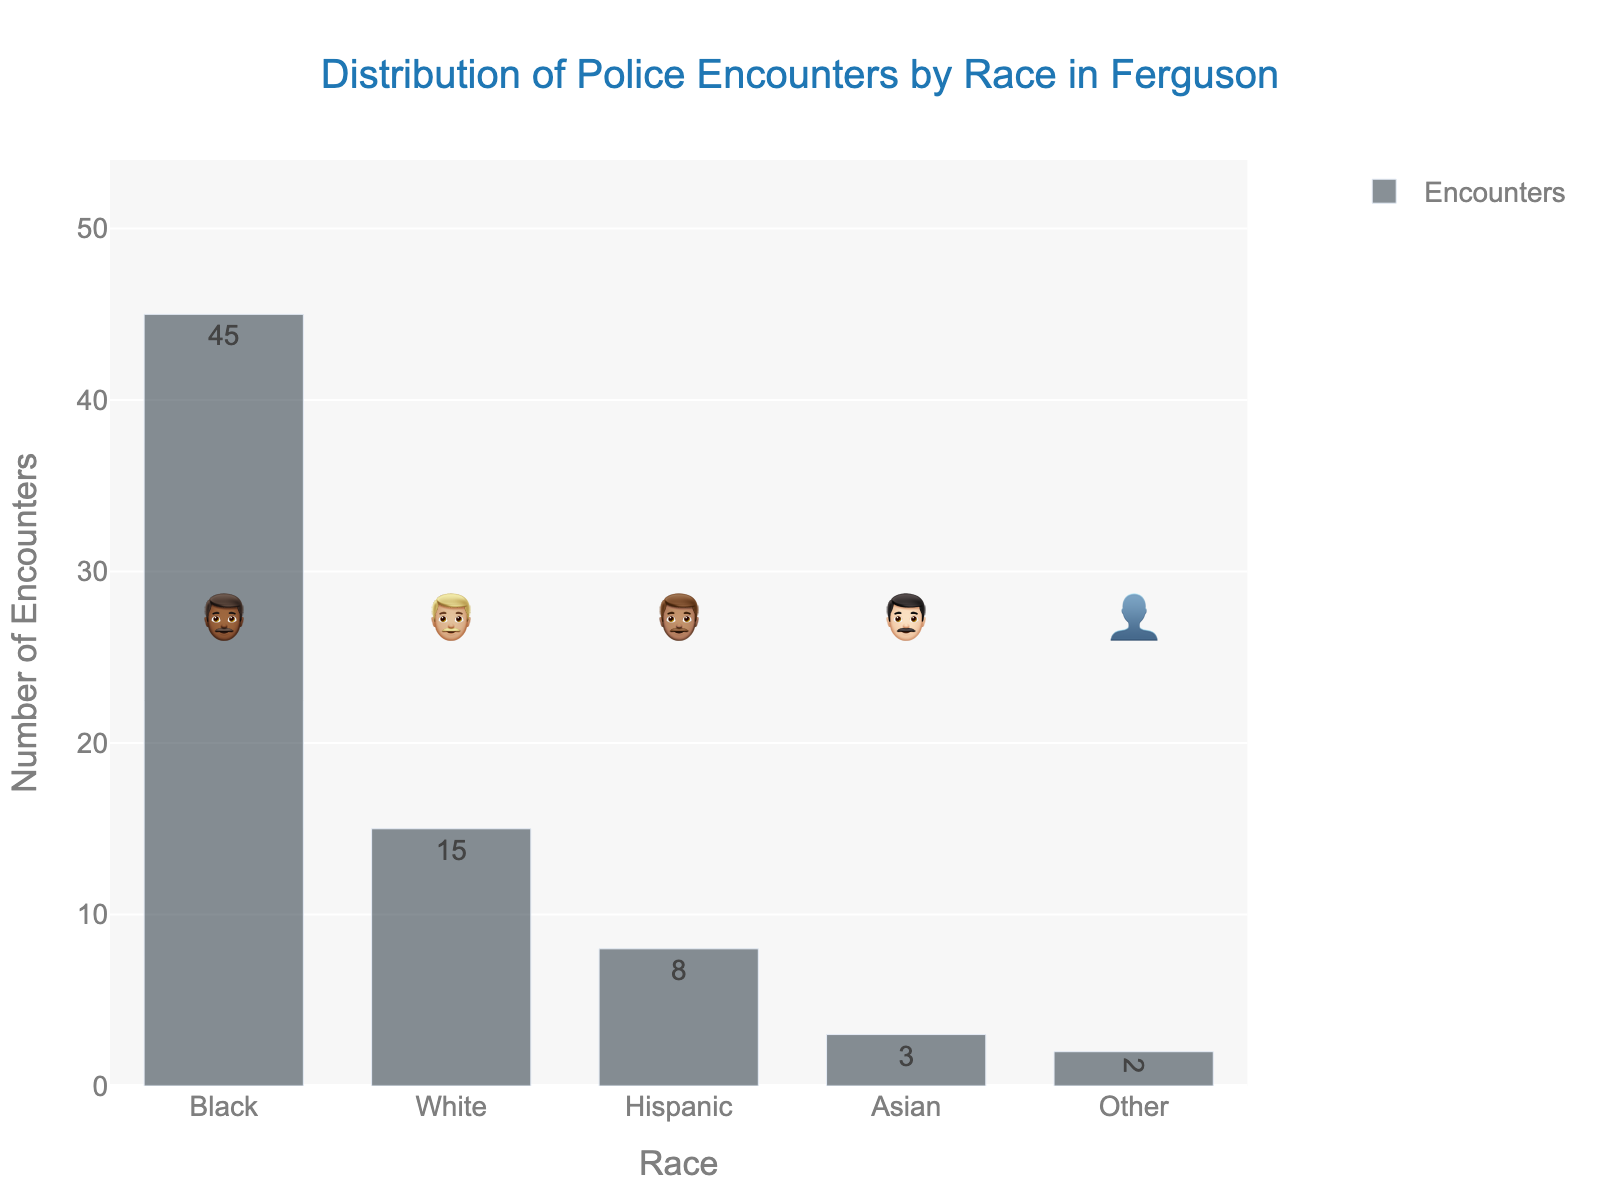what is the title of the figure? The title is displayed at the top and provides a summary of what the figure is about. In this case, the title reads "Distribution of Police Encounters by Race in Ferguson."
Answer: Distribution of Police Encounters by Race in Ferguson Which race has the highest number of police encounters? The bar representing "Black" has the highest value, as visually indicated by its height, and the text label confirms it at 45 encounters.
Answer: Black How many police encounters involve White individuals? The bar labeled "White" has a value of 15, which is also confirmed by the text label on the bar itself.
Answer: 15 What is the total number of police encounters across all races? Sum all encounters: 45 (Black) + 15 (White) + 8 (Hispanic) + 3 (Asian) + 2 (Other) = 73.
Answer: 73 How does the number of encounters involving Hispanic individuals compare to those involving Asian individuals? Hispanic encounters are represented as 8 and Asian encounters as 3, so Hispanics have more encounters than Asians.
Answer: Hispanics have more encounters What is the difference in the number of encounters between the race with the highest and the race with the lowest encounters? Subtract the lowest value (2 for "Other") from the highest value (45 for "Black"): 45 - 2 = 43.
Answer: 43 What fraction of police encounters involve Hispanic individuals compared to Black individuals? The number of Hispanic encounters is 8 and Black encounters is 45. The fraction is 8/45, which simplifies, but keeping it in fraction form is most straightforward.
Answer: 8/45 Which two races have the closest number of police encounters? The encounters for Asian (3) and Other (2) are closest to each other, with a difference of just 1.
Answer: Asian and Other What does each emoji represent in the figure? Each emoji represents the race category it is aligned with: 👨🏾 for Black, 👨🏼 for White, 👨🏽 for Hispanic, 👨🏻 for Asian, and 👤 for Other.
Answer: Different races What is the average number of police encounters per race? Sum the total encounters (73) and divide by the number of races (5): 73/5 = 14.6.
Answer: 14.6 